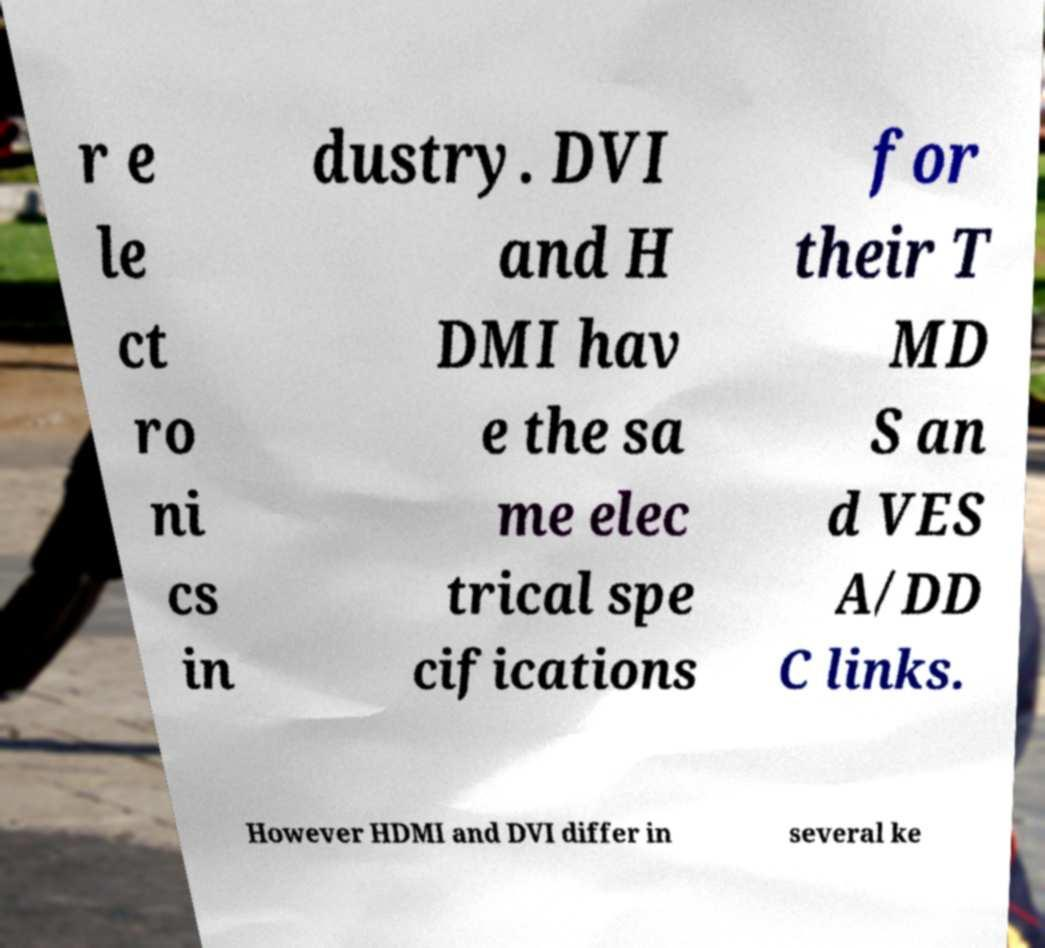Could you assist in decoding the text presented in this image and type it out clearly? r e le ct ro ni cs in dustry. DVI and H DMI hav e the sa me elec trical spe cifications for their T MD S an d VES A/DD C links. However HDMI and DVI differ in several ke 